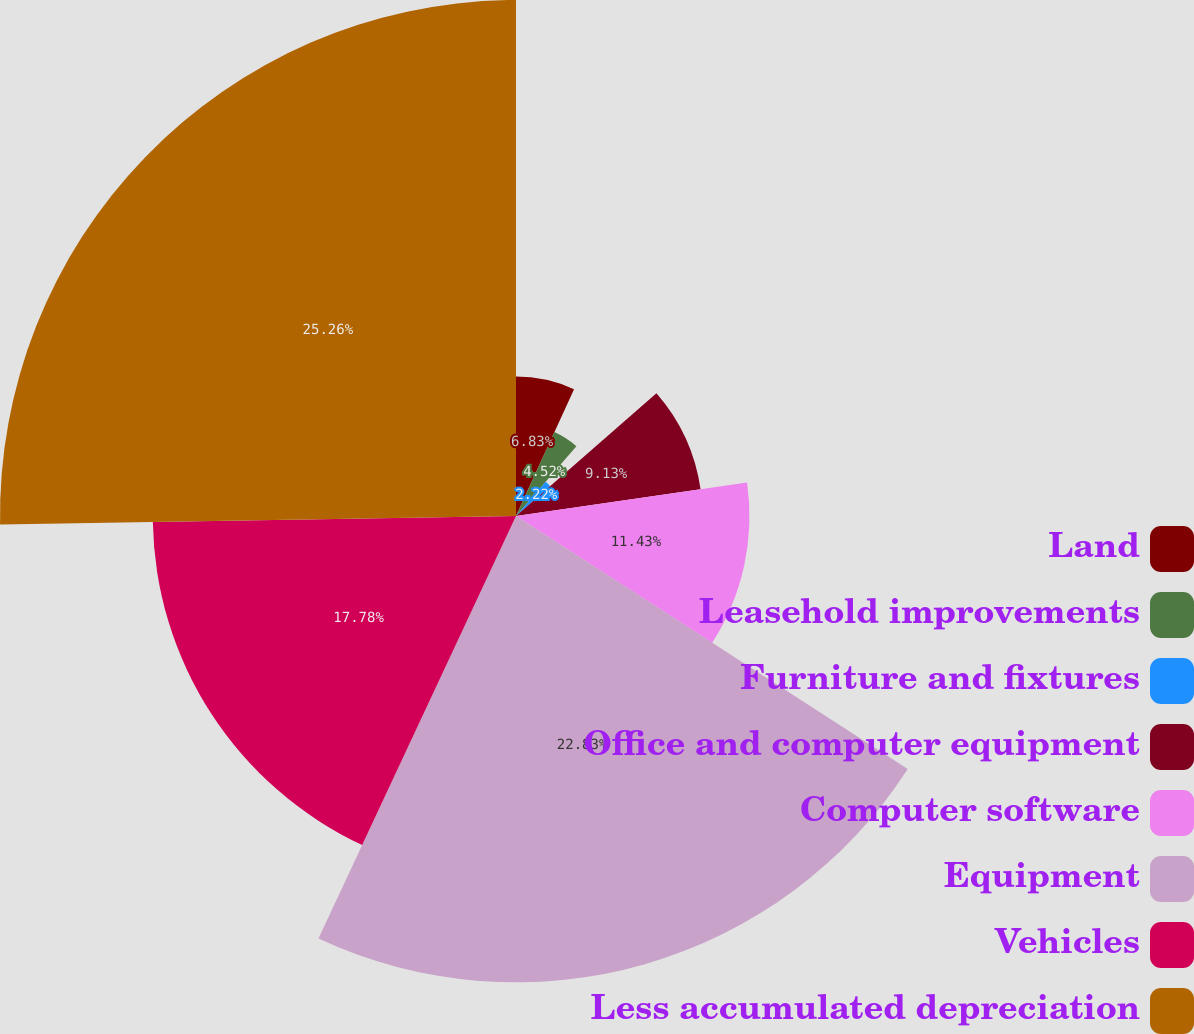<chart> <loc_0><loc_0><loc_500><loc_500><pie_chart><fcel>Land<fcel>Leasehold improvements<fcel>Furniture and fixtures<fcel>Office and computer equipment<fcel>Computer software<fcel>Equipment<fcel>Vehicles<fcel>Less accumulated depreciation<nl><fcel>6.83%<fcel>4.52%<fcel>2.22%<fcel>9.13%<fcel>11.43%<fcel>22.83%<fcel>17.78%<fcel>25.26%<nl></chart> 